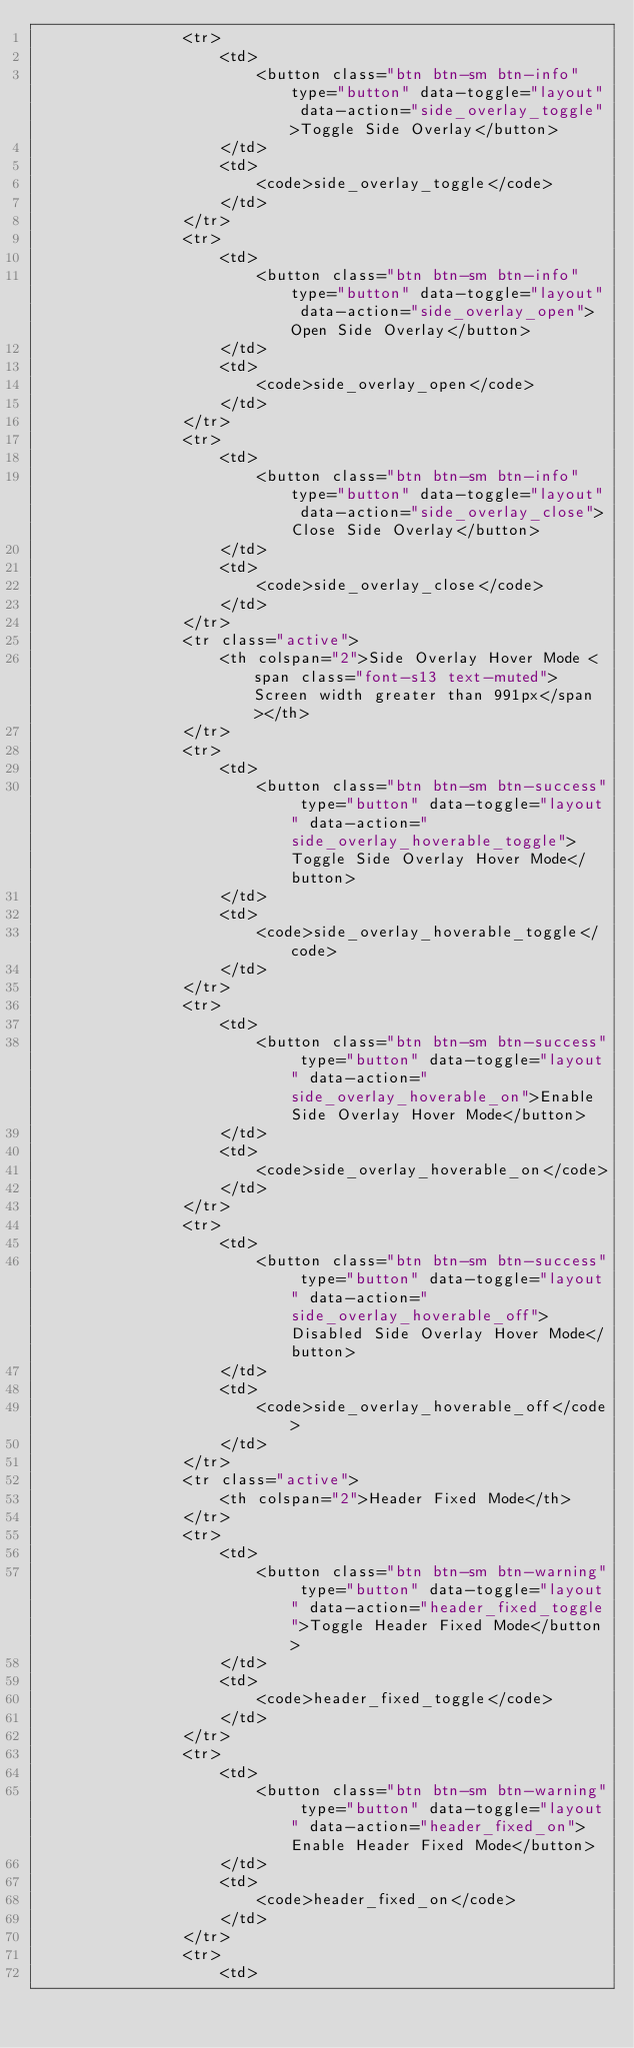<code> <loc_0><loc_0><loc_500><loc_500><_PHP_>                <tr>
                    <td>
                        <button class="btn btn-sm btn-info" type="button" data-toggle="layout" data-action="side_overlay_toggle">Toggle Side Overlay</button>
                    </td>
                    <td>
                        <code>side_overlay_toggle</code>
                    </td>
                </tr>
                <tr>
                    <td>
                        <button class="btn btn-sm btn-info" type="button" data-toggle="layout" data-action="side_overlay_open">Open Side Overlay</button>
                    </td>
                    <td>
                        <code>side_overlay_open</code>
                    </td>
                </tr>
                <tr>
                    <td>
                        <button class="btn btn-sm btn-info" type="button" data-toggle="layout" data-action="side_overlay_close">Close Side Overlay</button>
                    </td>
                    <td>
                        <code>side_overlay_close</code>
                    </td>
                </tr>
                <tr class="active">
                    <th colspan="2">Side Overlay Hover Mode <span class="font-s13 text-muted">Screen width greater than 991px</span></th>
                </tr>
                <tr>
                    <td>
                        <button class="btn btn-sm btn-success" type="button" data-toggle="layout" data-action="side_overlay_hoverable_toggle">Toggle Side Overlay Hover Mode</button>
                    </td>
                    <td>
                        <code>side_overlay_hoverable_toggle</code>
                    </td>
                </tr>
                <tr>
                    <td>
                        <button class="btn btn-sm btn-success" type="button" data-toggle="layout" data-action="side_overlay_hoverable_on">Enable Side Overlay Hover Mode</button>
                    </td>
                    <td>
                        <code>side_overlay_hoverable_on</code>
                    </td>
                </tr>
                <tr>
                    <td>
                        <button class="btn btn-sm btn-success" type="button" data-toggle="layout" data-action="side_overlay_hoverable_off">Disabled Side Overlay Hover Mode</button>
                    </td>
                    <td>
                        <code>side_overlay_hoverable_off</code>
                    </td>
                </tr>
                <tr class="active">
                    <th colspan="2">Header Fixed Mode</th>
                </tr>
                <tr>
                    <td>
                        <button class="btn btn-sm btn-warning" type="button" data-toggle="layout" data-action="header_fixed_toggle">Toggle Header Fixed Mode</button>
                    </td>
                    <td>
                        <code>header_fixed_toggle</code>
                    </td>
                </tr>
                <tr>
                    <td>
                        <button class="btn btn-sm btn-warning" type="button" data-toggle="layout" data-action="header_fixed_on">Enable Header Fixed Mode</button>
                    </td>
                    <td>
                        <code>header_fixed_on</code>
                    </td>
                </tr>
                <tr>
                    <td></code> 